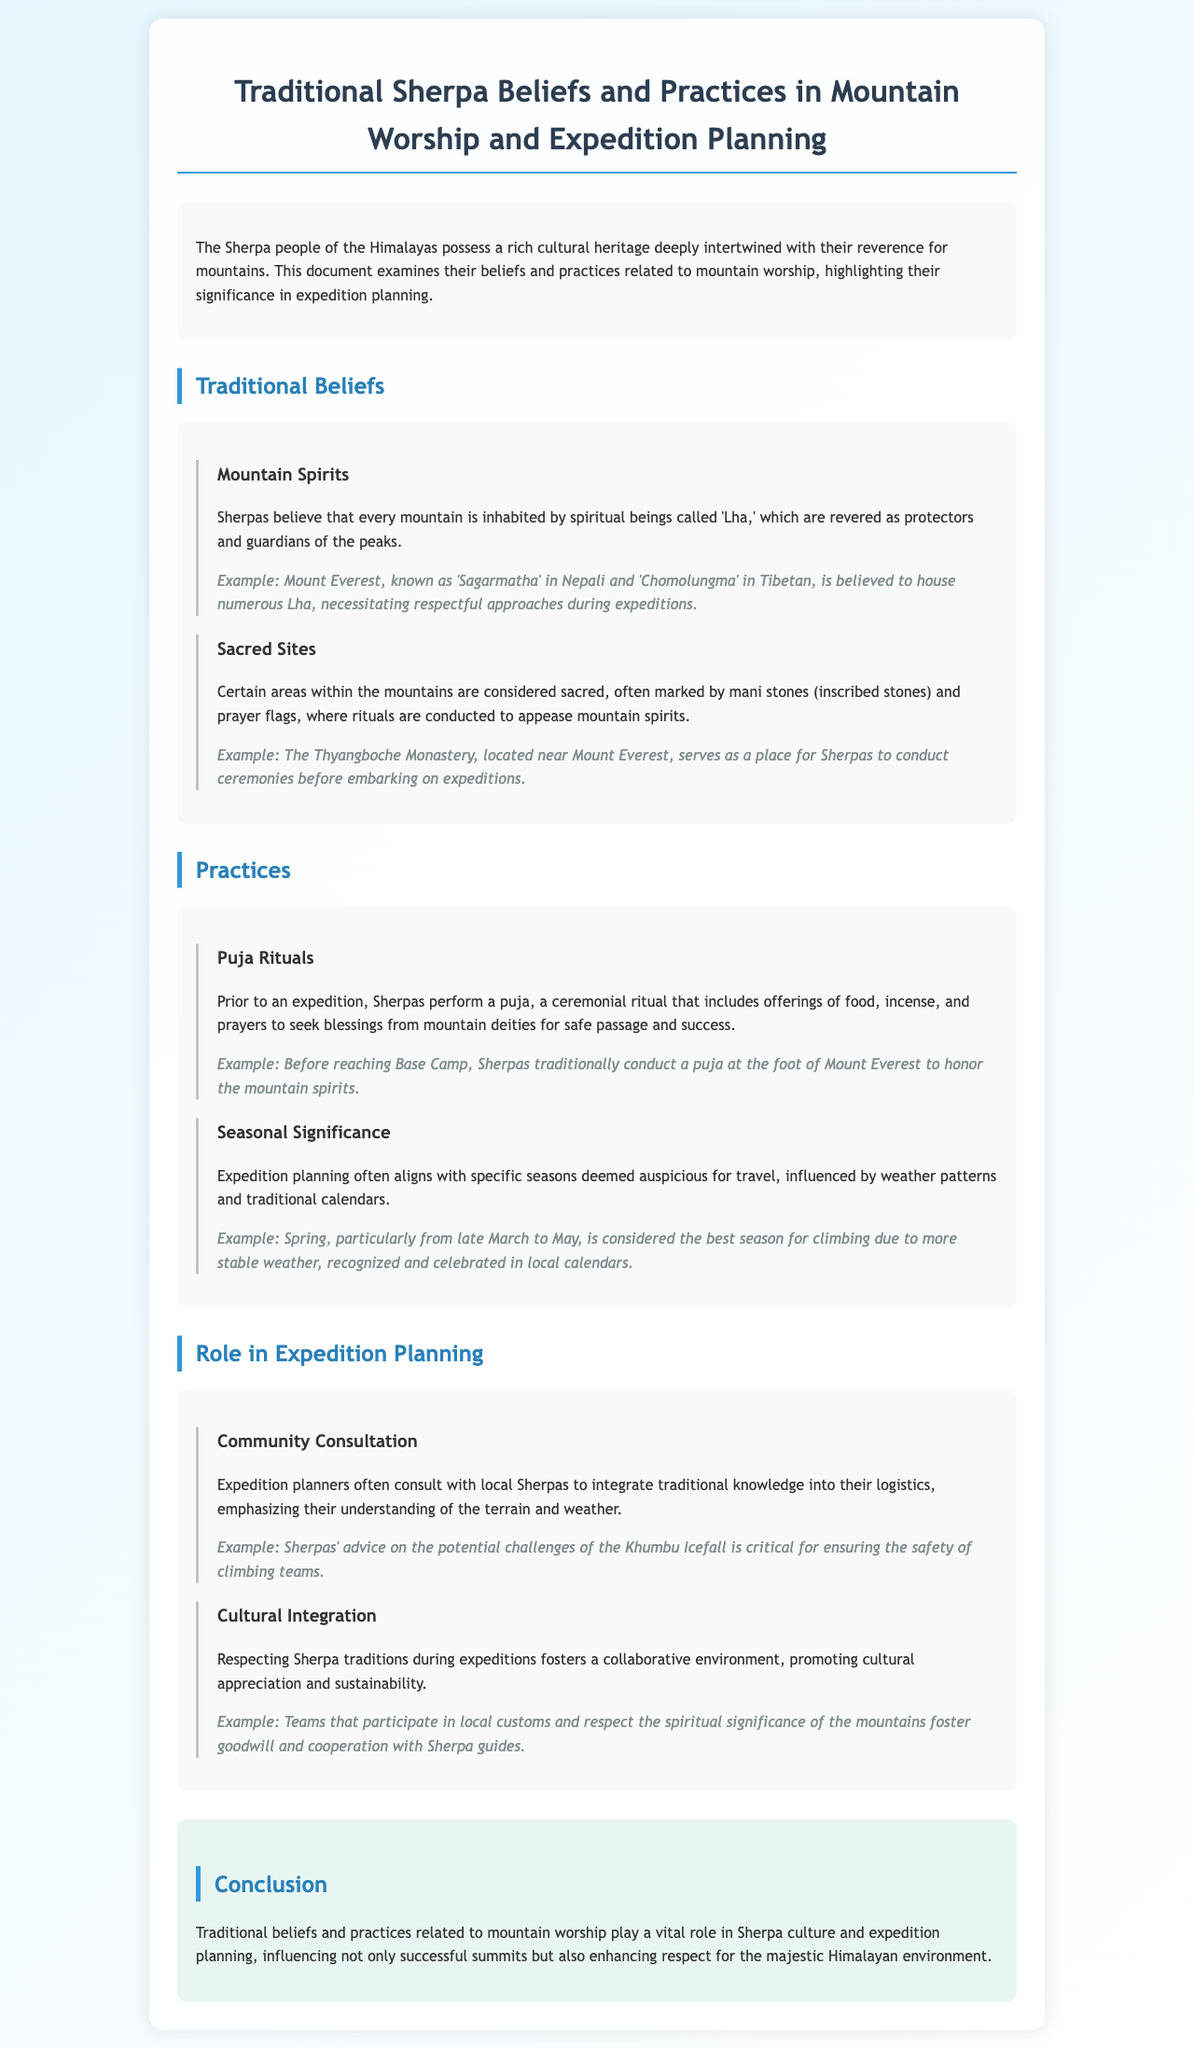What are mountain spirits called in Sherpa culture? The document states that mountain spirits are referred to as 'Lha,' which are considered protectors and guardians of the peaks.
Answer: Lha What is the significance of the Thyangboche Monastery? The document mentions that the Thyangboche Monastery serves as a place for Sherpas to conduct ceremonies before embarking on expeditions, marking its sacred importance.
Answer: Place for ceremonies What offerings are included in a puja ritual? According to the document, puja rituals include offerings of food, incense, and prayers to seek blessings from mountain deities.
Answer: Food, incense, and prayers During which season is climbing considered best according to the document? The document indicates that spring, particularly from late March to May, is considered the best season for climbing due to more stable weather.
Answer: Spring Why do expedition planners consult with local Sherpas? The document explains that expedition planners consult with local Sherpas to integrate traditional knowledge into logistics, focusing on their understanding of the terrain and weather.
Answer: Traditional knowledge What is one way that respecting Sherpa traditions benefits expeditions? The document highlights that respecting Sherpa traditions fosters a collaborative environment, enhancing cultural appreciation and sustainability during expeditions.
Answer: Fosters collaboration What is the main conclusion of the report? The report concludes that traditional beliefs and practices related to mountain worship play a vital role in Sherpa culture and expedition planning.
Answer: Vital role in culture and planning 